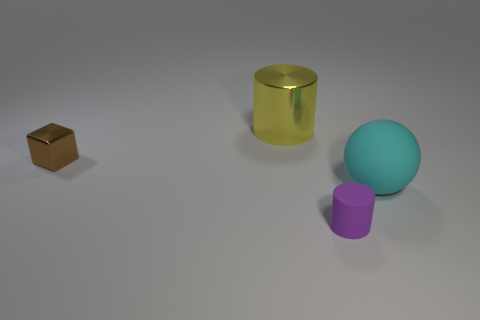There is a object that is behind the small brown metal thing; how big is it?
Offer a terse response. Large. What number of purple cylinders are the same size as the purple thing?
Give a very brief answer. 0. There is a brown block; does it have the same size as the cylinder to the right of the large metal thing?
Ensure brevity in your answer.  Yes. What number of things are either cyan shiny cubes or shiny things?
Your answer should be very brief. 2. What number of objects are the same color as the tiny cylinder?
Ensure brevity in your answer.  0. There is a yellow metallic object that is the same size as the cyan rubber sphere; what shape is it?
Your answer should be very brief. Cylinder. Are there any other brown things that have the same shape as the brown thing?
Offer a very short reply. No. How many large yellow cylinders are the same material as the small brown block?
Your answer should be compact. 1. Do the big thing that is to the right of the big yellow metallic object and the small cube have the same material?
Offer a terse response. No. Are there more tiny purple rubber objects right of the large shiny object than yellow cylinders in front of the small purple rubber cylinder?
Make the answer very short. Yes. 